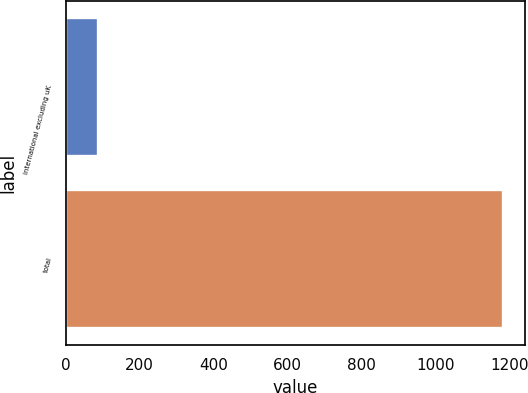<chart> <loc_0><loc_0><loc_500><loc_500><bar_chart><fcel>international excluding uK<fcel>total<nl><fcel>87<fcel>1183<nl></chart> 